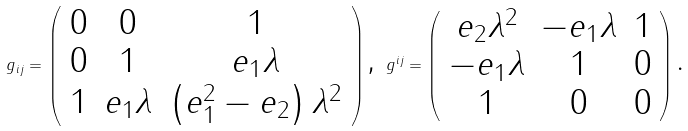<formula> <loc_0><loc_0><loc_500><loc_500>g _ { i j } = \left ( \begin{array} { c c c } 0 & 0 & 1 \\ 0 & 1 & e _ { 1 } \lambda \\ 1 & e _ { 1 } \lambda & \left ( e _ { 1 } ^ { 2 } - e _ { 2 } \right ) \lambda ^ { 2 } \end{array} \right ) \text {, } g ^ { i j } = \left ( \begin{array} { c c c } e _ { 2 } \lambda ^ { 2 } & - e _ { 1 } \lambda & 1 \\ - e _ { 1 } \lambda & 1 & 0 \\ 1 & 0 & 0 \end{array} \right ) \text {. }</formula> 